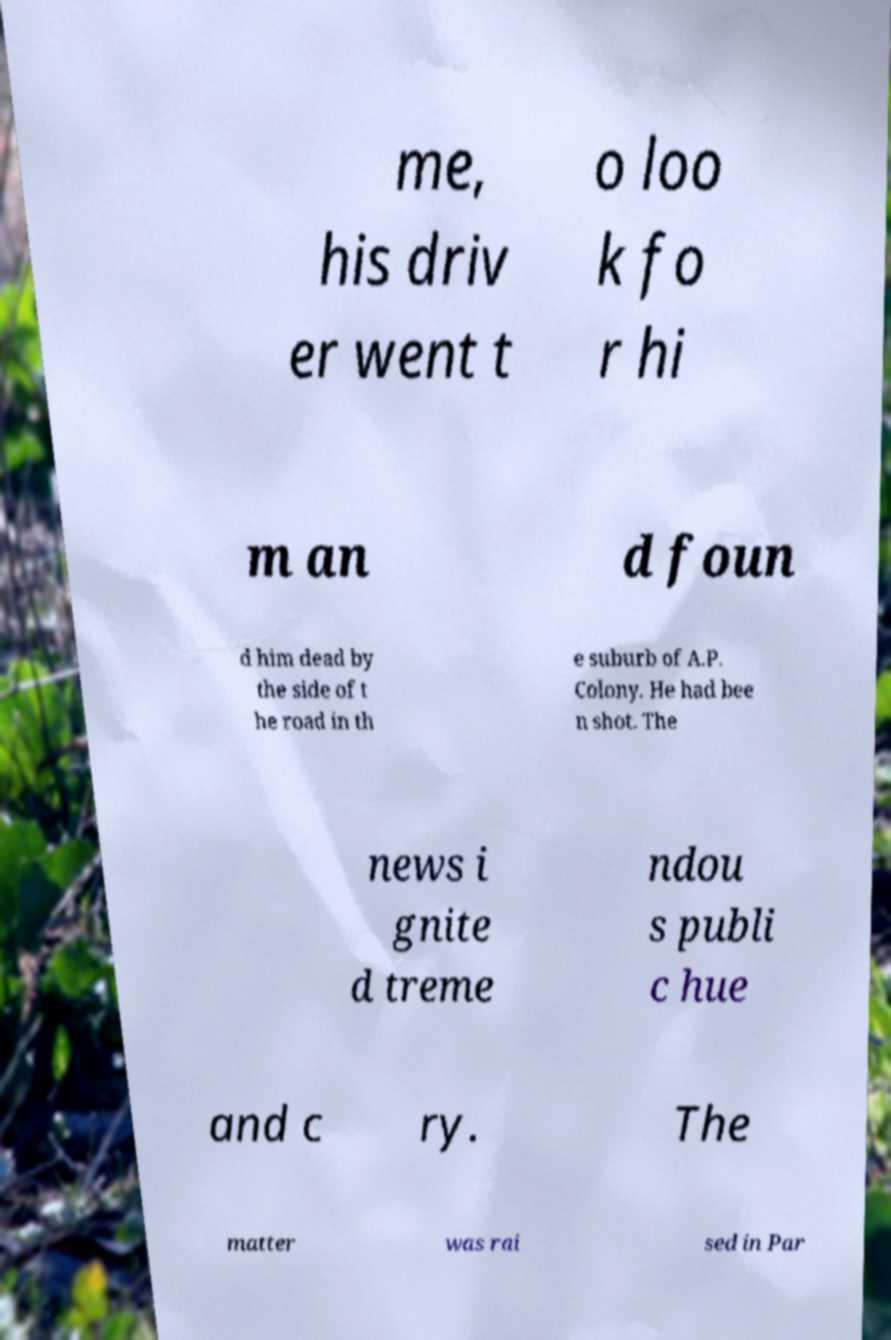Please read and relay the text visible in this image. What does it say? me, his driv er went t o loo k fo r hi m an d foun d him dead by the side of t he road in th e suburb of A.P. Colony. He had bee n shot. The news i gnite d treme ndou s publi c hue and c ry. The matter was rai sed in Par 